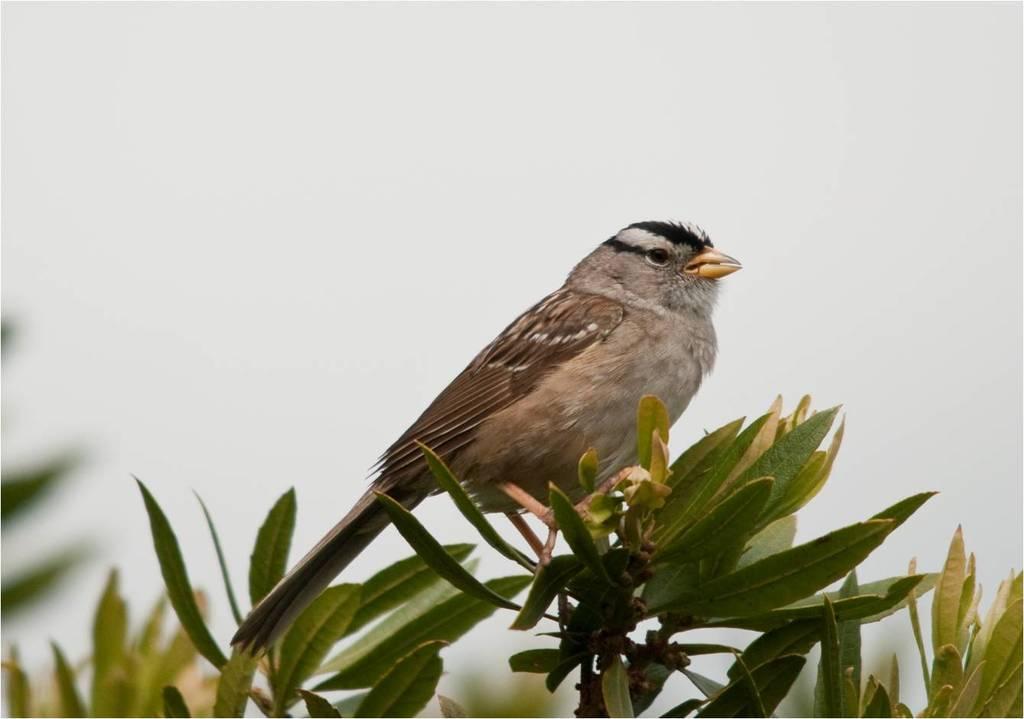How would you summarize this image in a sentence or two? In this image we can see a bird is sitting on stem of a plant and so many leaves are there to the plant. 